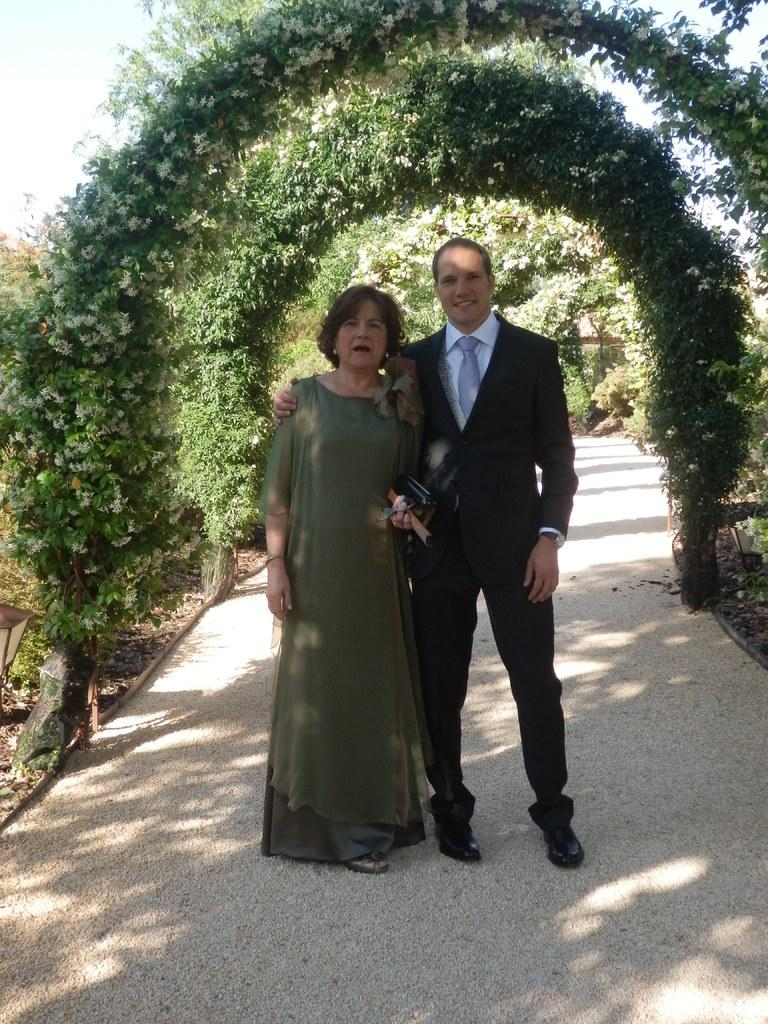Who are the people in the image? There is a man and a woman in the image. What are the man and woman doing in the image? Both the man and woman are standing on a path. What can be seen in the background of the image? There are green leaf arches and the sky visible in the background. What type of seed is being used to ring the bell in the image? There is no bell or seed present in the image. What is the man and woman eating for breakfast in the image? There is no breakfast depicted in the image; it only shows the man and woman standing on a path. 